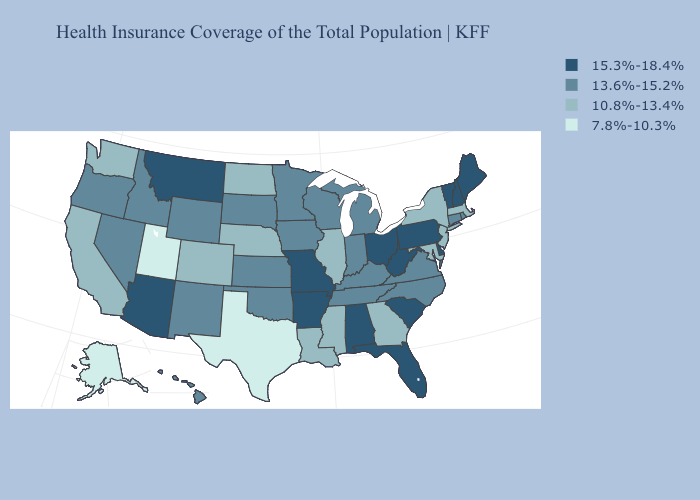Among the states that border New York , does Pennsylvania have the highest value?
Write a very short answer. Yes. What is the highest value in states that border Utah?
Short answer required. 15.3%-18.4%. Does Missouri have the highest value in the USA?
Quick response, please. Yes. Name the states that have a value in the range 10.8%-13.4%?
Be succinct. California, Colorado, Georgia, Illinois, Louisiana, Maryland, Massachusetts, Mississippi, Nebraska, New Jersey, New York, North Dakota, Washington. What is the value of Hawaii?
Short answer required. 13.6%-15.2%. Name the states that have a value in the range 15.3%-18.4%?
Short answer required. Alabama, Arizona, Arkansas, Delaware, Florida, Maine, Missouri, Montana, New Hampshire, Ohio, Pennsylvania, South Carolina, Vermont, West Virginia. Name the states that have a value in the range 7.8%-10.3%?
Answer briefly. Alaska, Texas, Utah. Among the states that border West Virginia , which have the highest value?
Give a very brief answer. Ohio, Pennsylvania. What is the value of Hawaii?
Be succinct. 13.6%-15.2%. What is the highest value in the MidWest ?
Keep it brief. 15.3%-18.4%. Name the states that have a value in the range 7.8%-10.3%?
Write a very short answer. Alaska, Texas, Utah. Does California have a lower value than Montana?
Short answer required. Yes. Does Delaware have the same value as West Virginia?
Short answer required. Yes. What is the highest value in the USA?
Short answer required. 15.3%-18.4%. Does North Carolina have a lower value than Missouri?
Be succinct. Yes. 